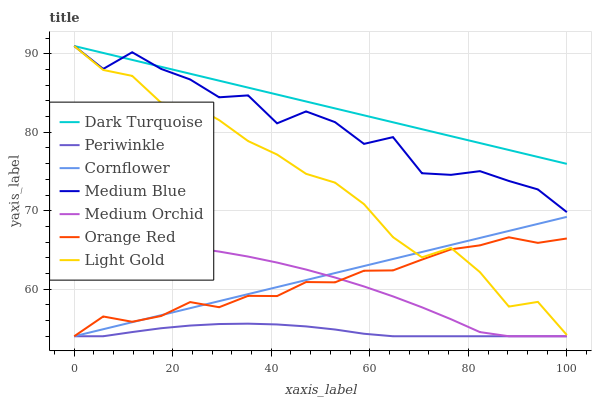Does Periwinkle have the minimum area under the curve?
Answer yes or no. Yes. Does Dark Turquoise have the maximum area under the curve?
Answer yes or no. Yes. Does Medium Orchid have the minimum area under the curve?
Answer yes or no. No. Does Medium Orchid have the maximum area under the curve?
Answer yes or no. No. Is Cornflower the smoothest?
Answer yes or no. Yes. Is Medium Blue the roughest?
Answer yes or no. Yes. Is Dark Turquoise the smoothest?
Answer yes or no. No. Is Dark Turquoise the roughest?
Answer yes or no. No. Does Cornflower have the lowest value?
Answer yes or no. Yes. Does Dark Turquoise have the lowest value?
Answer yes or no. No. Does Light Gold have the highest value?
Answer yes or no. Yes. Does Medium Orchid have the highest value?
Answer yes or no. No. Is Medium Orchid less than Light Gold?
Answer yes or no. Yes. Is Light Gold greater than Medium Orchid?
Answer yes or no. Yes. Does Cornflower intersect Orange Red?
Answer yes or no. Yes. Is Cornflower less than Orange Red?
Answer yes or no. No. Is Cornflower greater than Orange Red?
Answer yes or no. No. Does Medium Orchid intersect Light Gold?
Answer yes or no. No. 